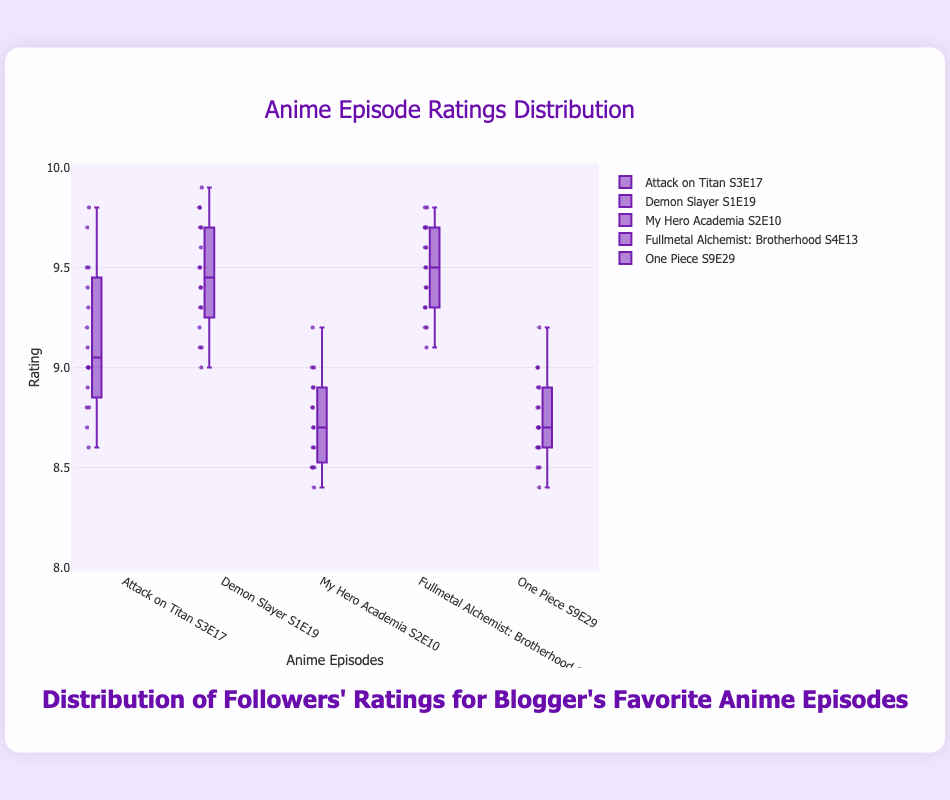What is the title of the plot? The title is usually at the top of the plot and directly states what the plot is about.
Answer: Distribution of Followers' Ratings for Blogger's Favorite Anime Episodes What is the range of ratings on the y-axis? Look for the values at the bottom and top of the y-axis.
Answer: 8 to 10 Which anime episode has the highest median rating? Compare the median line, which is usually the center line inside each box, for each episode.
Answer: Demon Slayer S1E19 What is the interquartile range (IQR) for Attack on Titan S3E17? The IQR is the range between the first quartile (bottom of the box) and the third quartile (top of the box).
Answer: 9.4 - 8.8 = 0.6 Which episode has the most variability in ratings? Look for the episode with the largest range between the bottom and top whiskers.
Answer: Fullmetal Alchemist: Brotherhood S4E13 For My Hero Academia S2E10, what is the median rating? The median is the line inside the box.
Answer: 8.7 Which episode has the lowest lower whisker value? Identify the episode with the lowest point extending from the box (lower whisker).
Answer: My Hero Academia S2E10 What is the difference between the maximum rating for One Piece S9E29 and the minimum rating for Demon Slayer S1E19? Identify the highest value (top whisker) for One Piece S9E29 and the lowest value (bottom whisker) for Demon Slayer S1E19, then subtract the latter from the former.
Answer: 9.2 - 9.0 = 0.2 How many episodes have their median ratings above 9.0? Identify the episodes with the line inside the box (median) positioned above the 9.0 mark.
Answer: 3 (Attack on Titan S3E17, Demon Slayer S1E19, Fullmetal Alchemist: Brotherhood S4E13) Which episode has an outlier rating and what is it? Look for individual points separated from the whiskers; these are outliers.
Answer: Attack on Titan S3E17, with a rating of 8.6 